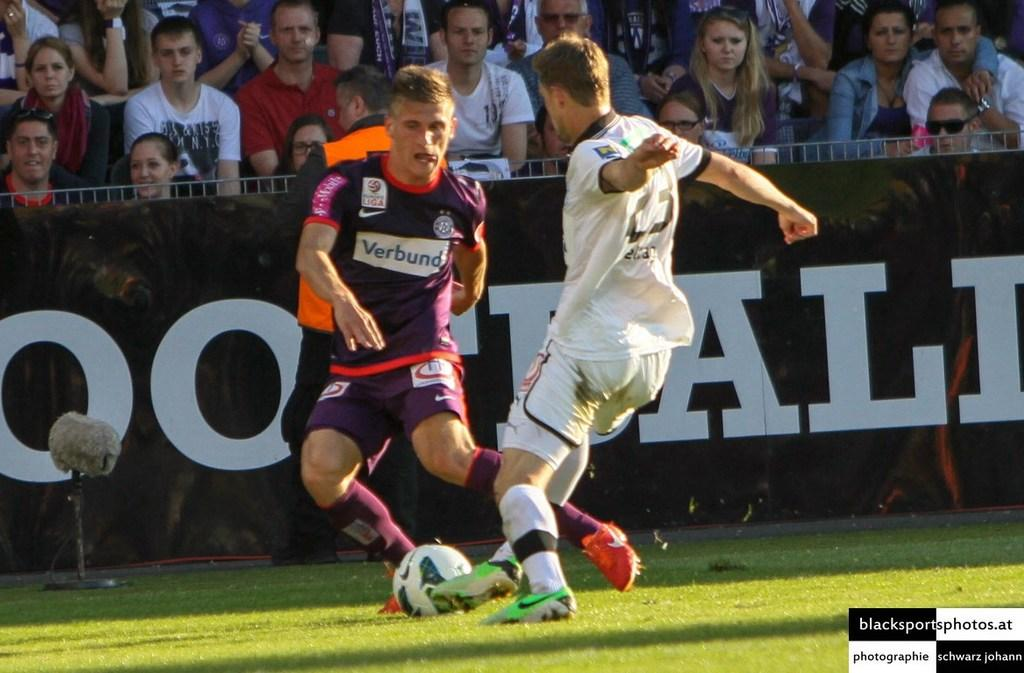<image>
Render a clear and concise summary of the photo. Soccer players with one with a jersey that says verbund 